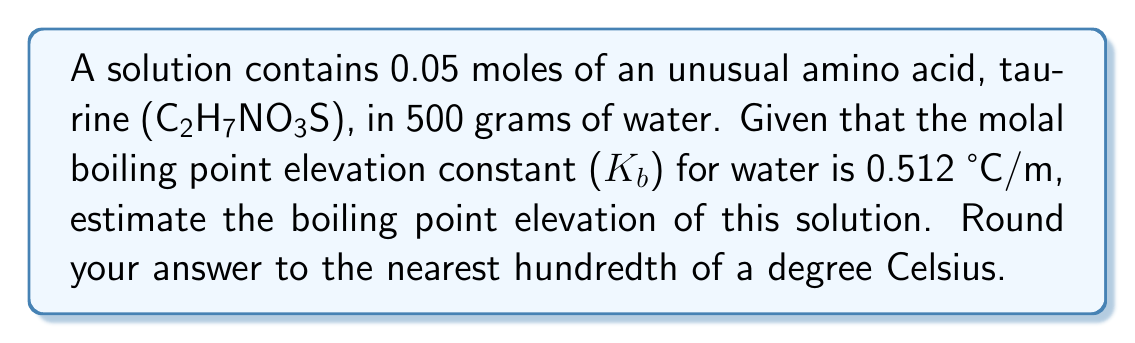What is the answer to this math problem? To estimate the boiling point elevation, we'll use the formula:

$$\Delta T_b = K_b \cdot m$$

Where:
$\Delta T_b$ = boiling point elevation
$K_b$ = molal boiling point elevation constant
$m$ = molality of the solution

Step 1: Calculate the molality of the solution.
Molality = moles of solute / kg of solvent
$$m = \frac{0.05 \text{ mol}}{0.5 \text{ kg}} = 0.1 \text{ mol/kg}$$

Step 2: Apply the formula for boiling point elevation.
$$\Delta T_b = 0.512 \text{ °C/m} \cdot 0.1 \text{ m} = 0.0512 \text{ °C}$$

Step 3: Round the result to the nearest hundredth.
$$0.0512 \text{ °C} \approx 0.05 \text{ °C}$$
Answer: 0.05 °C 